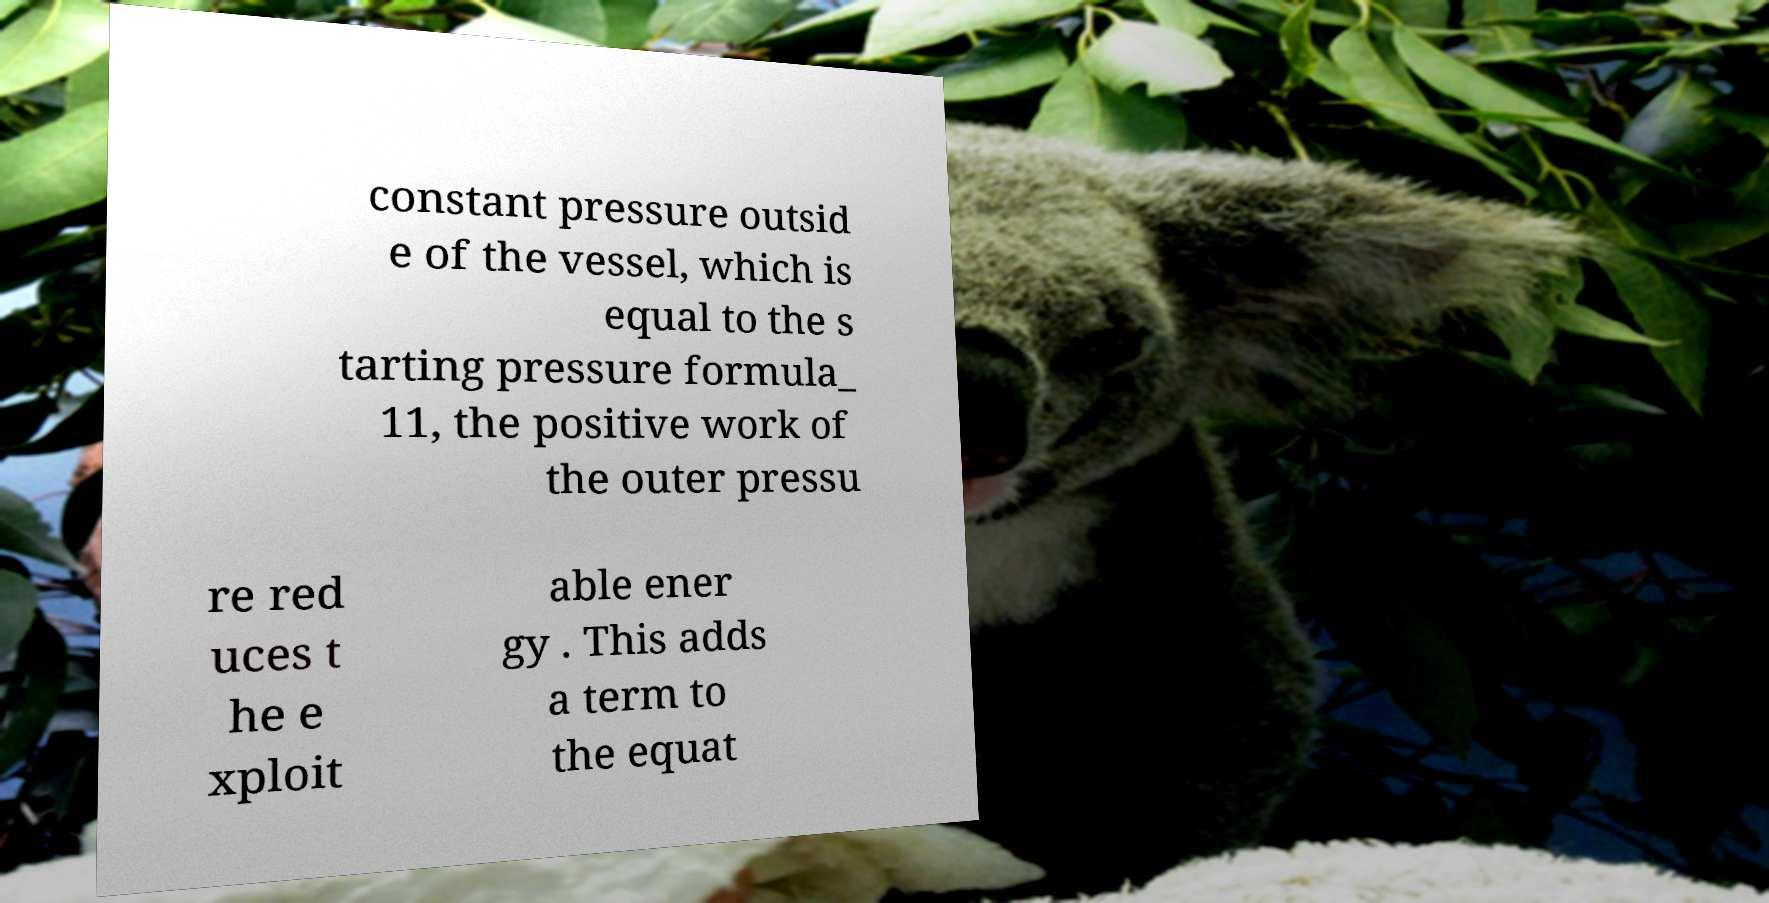Please read and relay the text visible in this image. What does it say? constant pressure outsid e of the vessel, which is equal to the s tarting pressure formula_ 11, the positive work of the outer pressu re red uces t he e xploit able ener gy . This adds a term to the equat 